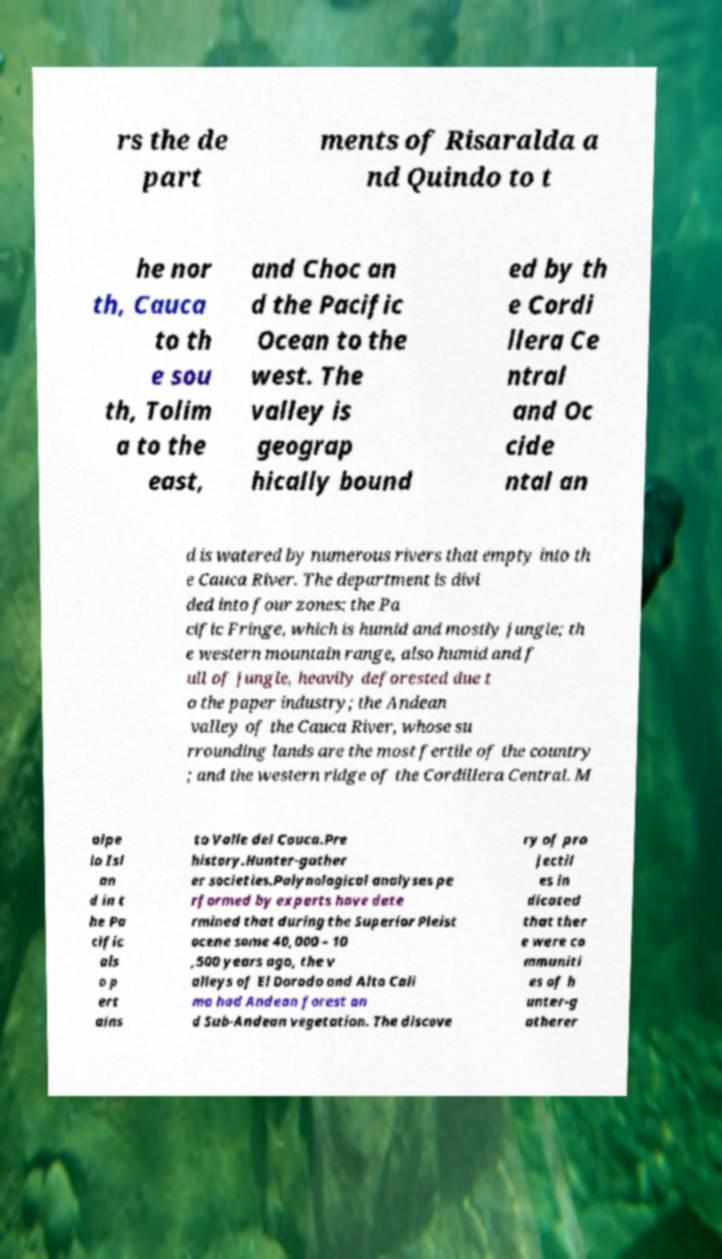There's text embedded in this image that I need extracted. Can you transcribe it verbatim? rs the de part ments of Risaralda a nd Quindo to t he nor th, Cauca to th e sou th, Tolim a to the east, and Choc an d the Pacific Ocean to the west. The valley is geograp hically bound ed by th e Cordi llera Ce ntral and Oc cide ntal an d is watered by numerous rivers that empty into th e Cauca River. The department is divi ded into four zones: the Pa cific Fringe, which is humid and mostly jungle; th e western mountain range, also humid and f ull of jungle, heavily deforested due t o the paper industry; the Andean valley of the Cauca River, whose su rrounding lands are the most fertile of the country ; and the western ridge of the Cordillera Central. M alpe lo Isl an d in t he Pa cific als o p ert ains to Valle del Cauca.Pre history.Hunter-gather er societies.Palynological analyses pe rformed by experts have dete rmined that during the Superior Pleist ocene some 40,000 – 10 ,500 years ago, the v alleys of El Dorado and Alto Cali ma had Andean forest an d Sub-Andean vegetation. The discove ry of pro jectil es in dicated that ther e were co mmuniti es of h unter-g atherer 